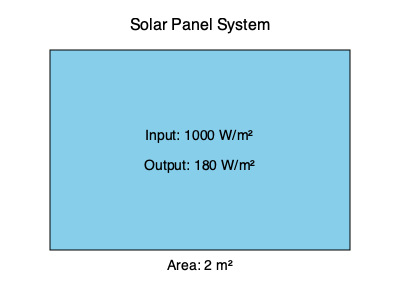A solar panel system receives an input of 1000 W/m² of solar radiation and produces an electrical output of 180 W/m². If the solar panel has an area of 2 m², calculate the overall efficiency of the system. To calculate the efficiency of the solar panel system, we need to follow these steps:

1. Calculate the total input power:
   Input power = Solar radiation × Panel area
   $P_{in} = 1000 \text{ W/m²} \times 2 \text{ m²} = 2000 \text{ W}$

2. Calculate the total output power:
   Output power = Electrical output × Panel area
   $P_{out} = 180 \text{ W/m²} \times 2 \text{ m²} = 360 \text{ W}$

3. Calculate the efficiency using the formula:
   $\text{Efficiency} = \frac{\text{Output Power}}{\text{Input Power}} \times 100\%$

   $\text{Efficiency} = \frac{360 \text{ W}}{2000 \text{ W}} \times 100\%$

4. Simplify the fraction and calculate the percentage:
   $\text{Efficiency} = 0.18 \times 100\% = 18\%$

Therefore, the overall efficiency of the solar panel system is 18%.
Answer: 18% 